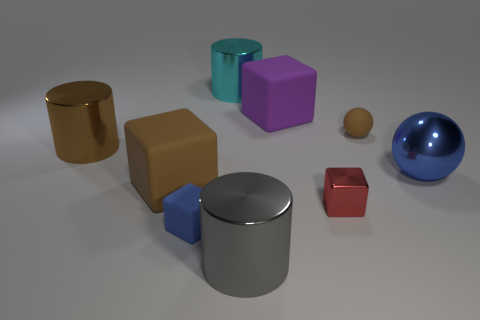Which objects appear to have reflective surfaces? The gold cylinder, silver cylinder, small red cube, and the large blue sphere all display reflective surfaces that suggest they might be made of materials like metal or shiny plastic. 